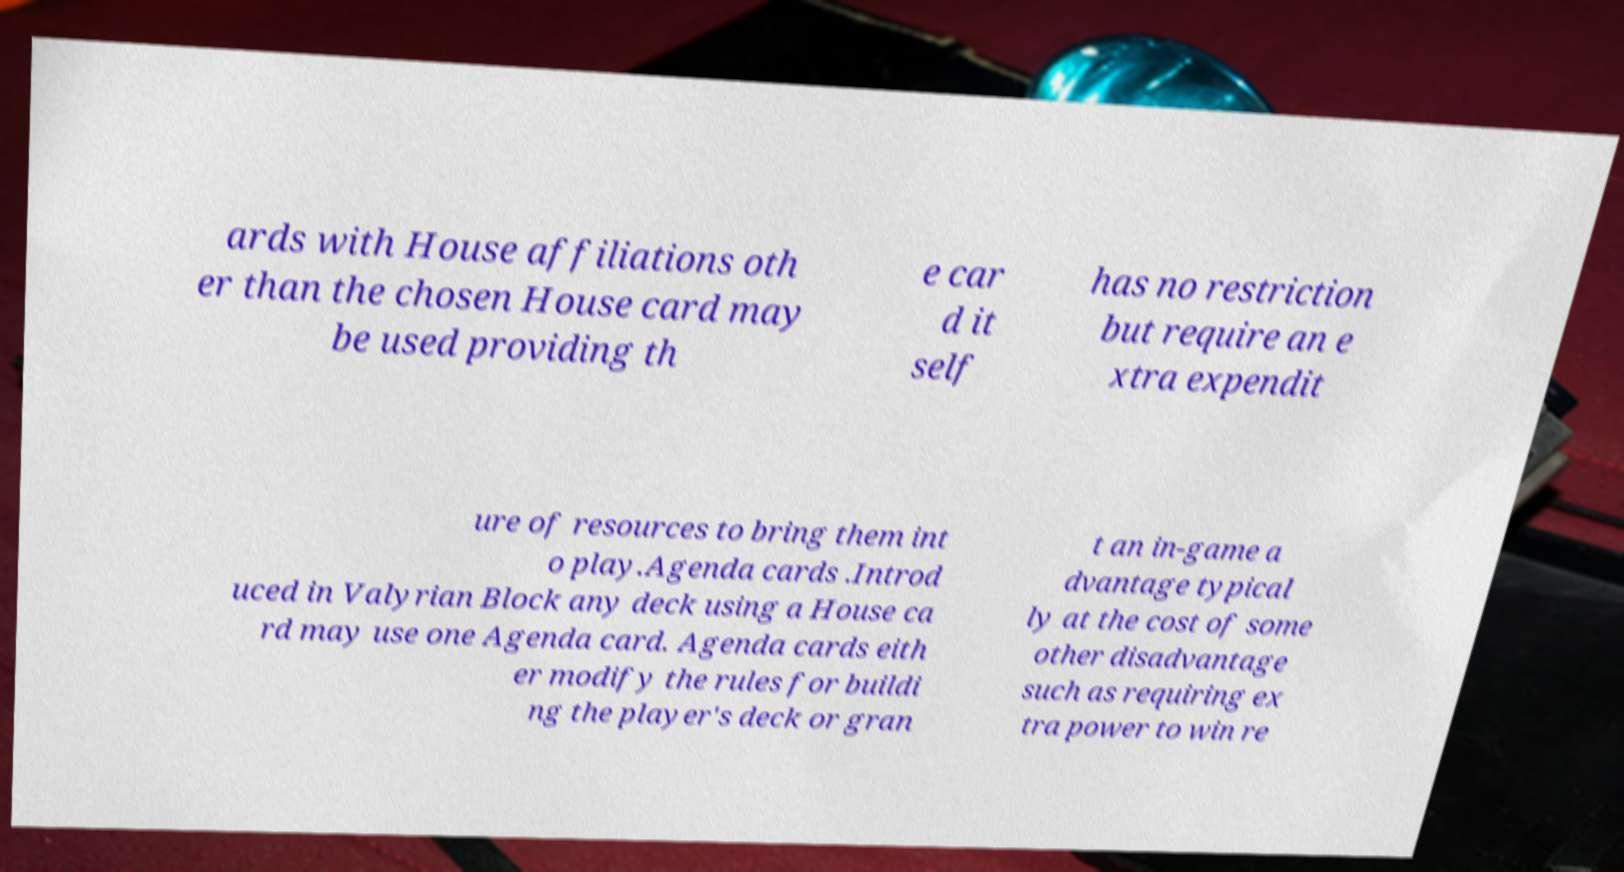Please identify and transcribe the text found in this image. ards with House affiliations oth er than the chosen House card may be used providing th e car d it self has no restriction but require an e xtra expendit ure of resources to bring them int o play.Agenda cards .Introd uced in Valyrian Block any deck using a House ca rd may use one Agenda card. Agenda cards eith er modify the rules for buildi ng the player's deck or gran t an in-game a dvantage typical ly at the cost of some other disadvantage such as requiring ex tra power to win re 